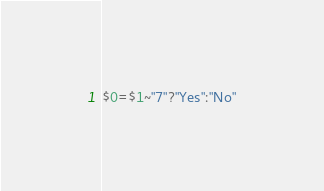<code> <loc_0><loc_0><loc_500><loc_500><_Awk_>$0=$1~"7"?"Yes":"No"</code> 